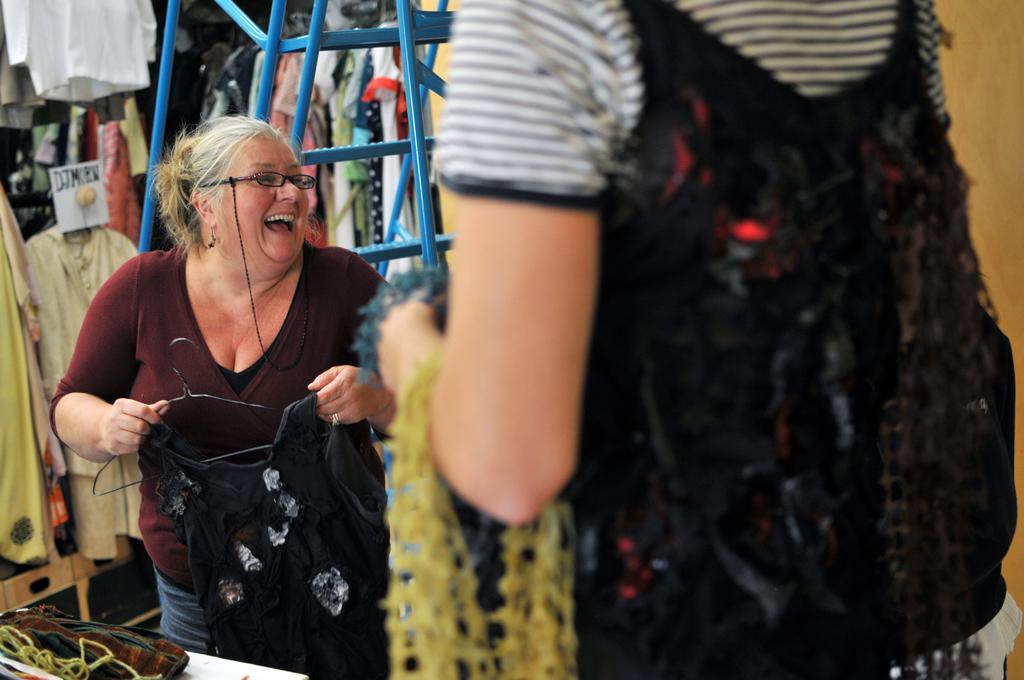Can you describe this image briefly? In this image we can see woman holding clothes. In the background we can see ladder, clothes and wall. 